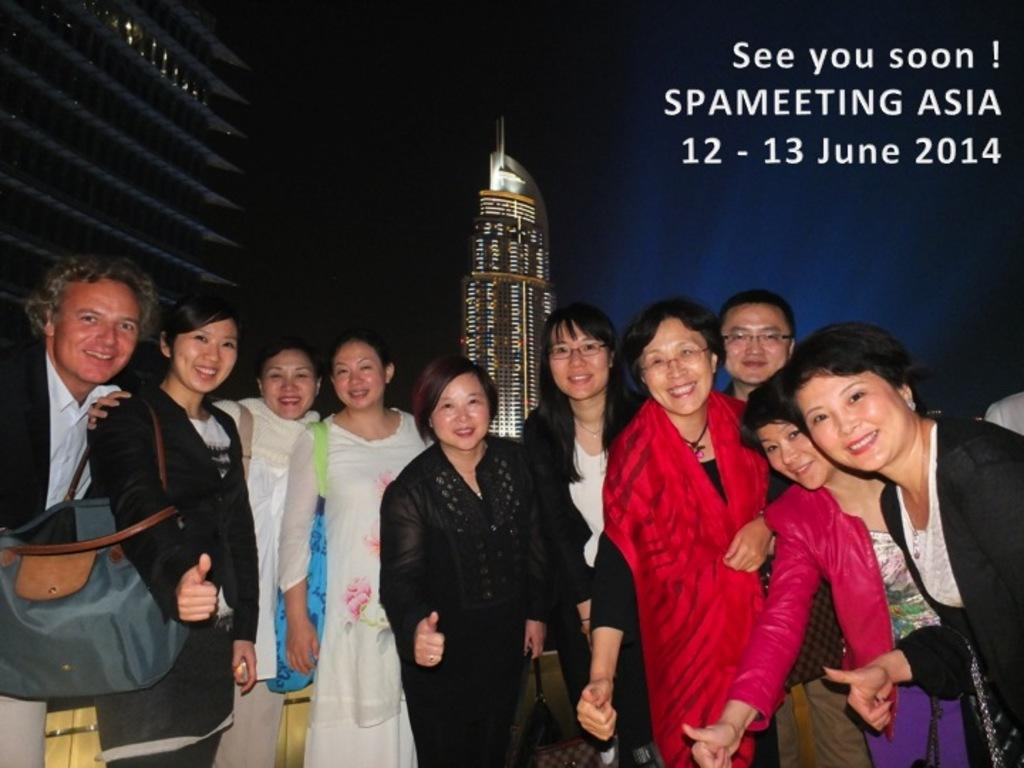What is happening in the image? There is a group of people in the image, and they are standing. How are the people in the image feeling? The people in the image are smiling. What can be seen in the background of the image? There are two buildings in the background of the image. What is the price of the glass in the image? There is no glass present in the image, so it is not possible to determine its price. 